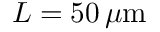Convert formula to latex. <formula><loc_0><loc_0><loc_500><loc_500>L = 5 0 \, \mu m</formula> 